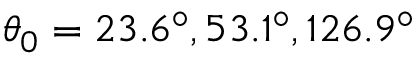<formula> <loc_0><loc_0><loc_500><loc_500>\theta _ { 0 } = 2 3 . 6 ^ { \circ } , 5 3 . 1 ^ { \circ } , 1 2 6 . 9 ^ { \circ }</formula> 